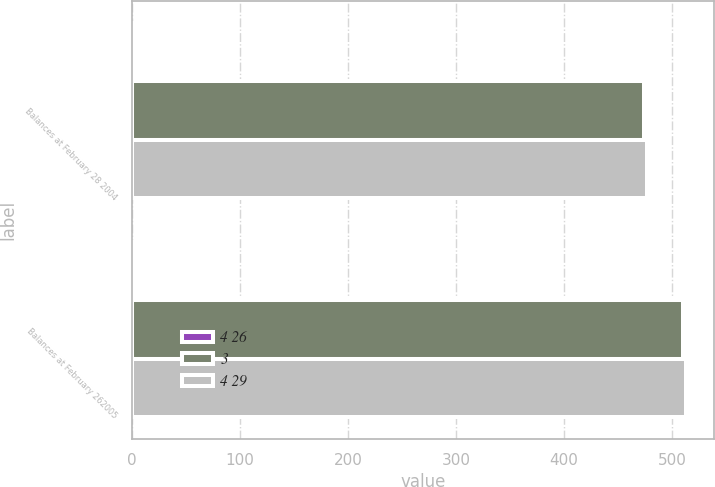Convert chart to OTSL. <chart><loc_0><loc_0><loc_500><loc_500><stacked_bar_chart><ecel><fcel>Balances at February 28 2004<fcel>Balances at February 262005<nl><fcel>4 26<fcel>3<fcel>3<nl><fcel>3<fcel>474<fcel>510<nl><fcel>4 29<fcel>477<fcel>513<nl></chart> 